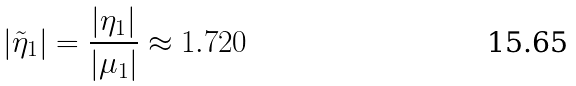<formula> <loc_0><loc_0><loc_500><loc_500>| \tilde { \eta } _ { 1 } | = \frac { | \eta _ { 1 } | } { | \mu _ { 1 } | } \approx 1 . 7 2 0</formula> 